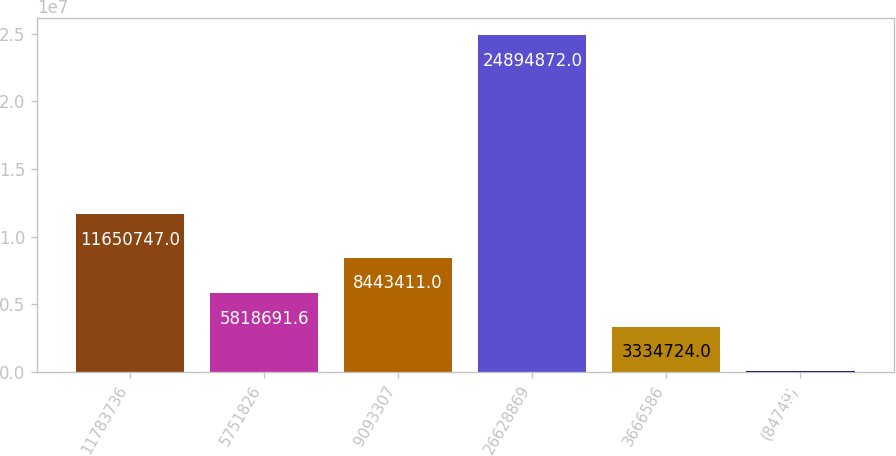Convert chart to OTSL. <chart><loc_0><loc_0><loc_500><loc_500><bar_chart><fcel>11783736<fcel>5751826<fcel>9093307<fcel>26628869<fcel>3666586<fcel>(84749)<nl><fcel>1.16507e+07<fcel>5.81869e+06<fcel>8.44341e+06<fcel>2.48949e+07<fcel>3.33472e+06<fcel>55196<nl></chart> 